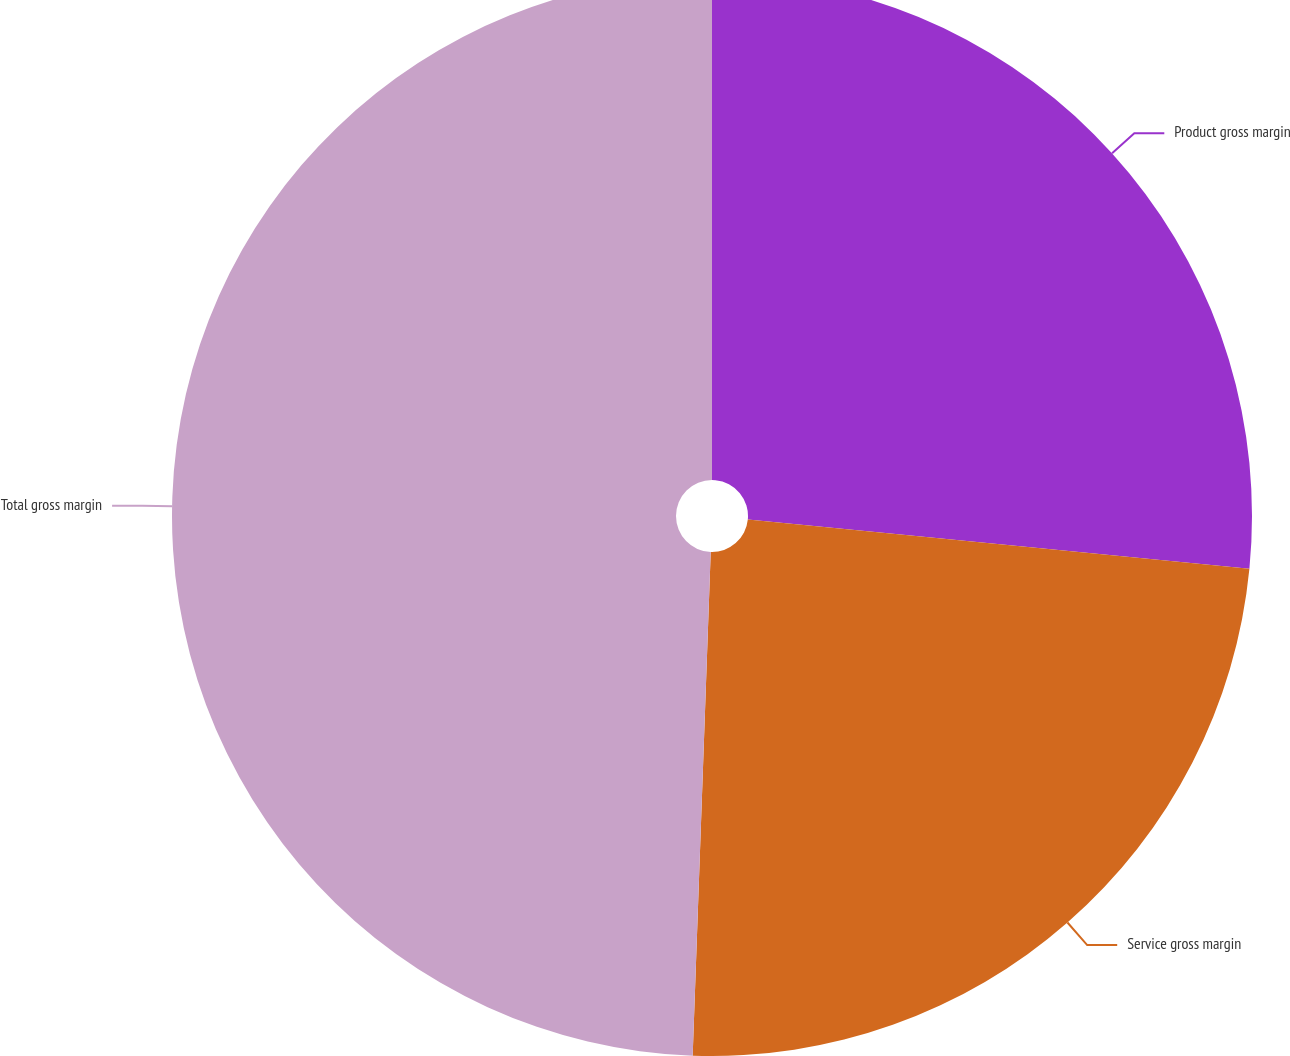<chart> <loc_0><loc_0><loc_500><loc_500><pie_chart><fcel>Product gross margin<fcel>Service gross margin<fcel>Total gross margin<nl><fcel>26.56%<fcel>24.01%<fcel>49.43%<nl></chart> 